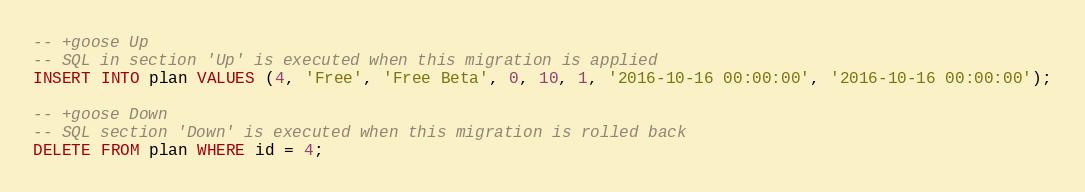Convert code to text. <code><loc_0><loc_0><loc_500><loc_500><_SQL_>-- +goose Up
-- SQL in section 'Up' is executed when this migration is applied
INSERT INTO plan VALUES (4, 'Free', 'Free Beta', 0, 10, 1, '2016-10-16 00:00:00', '2016-10-16 00:00:00');

-- +goose Down
-- SQL section 'Down' is executed when this migration is rolled back
DELETE FROM plan WHERE id = 4;
</code> 